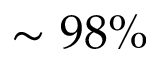Convert formula to latex. <formula><loc_0><loc_0><loc_500><loc_500>\sim 9 8 \%</formula> 